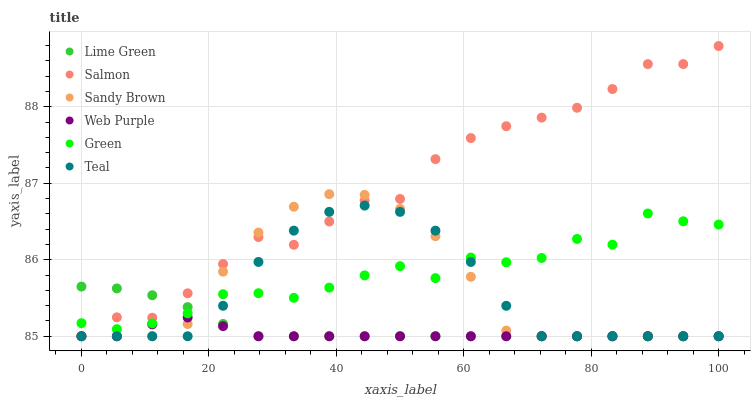Does Web Purple have the minimum area under the curve?
Answer yes or no. Yes. Does Salmon have the maximum area under the curve?
Answer yes or no. Yes. Does Salmon have the minimum area under the curve?
Answer yes or no. No. Does Web Purple have the maximum area under the curve?
Answer yes or no. No. Is Lime Green the smoothest?
Answer yes or no. Yes. Is Green the roughest?
Answer yes or no. Yes. Is Salmon the smoothest?
Answer yes or no. No. Is Salmon the roughest?
Answer yes or no. No. Does Sandy Brown have the lowest value?
Answer yes or no. Yes. Does Green have the lowest value?
Answer yes or no. No. Does Salmon have the highest value?
Answer yes or no. Yes. Does Web Purple have the highest value?
Answer yes or no. No. Is Web Purple less than Green?
Answer yes or no. Yes. Is Green greater than Web Purple?
Answer yes or no. Yes. Does Lime Green intersect Teal?
Answer yes or no. Yes. Is Lime Green less than Teal?
Answer yes or no. No. Is Lime Green greater than Teal?
Answer yes or no. No. Does Web Purple intersect Green?
Answer yes or no. No. 